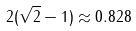Convert formula to latex. <formula><loc_0><loc_0><loc_500><loc_500>2 ( \sqrt { 2 } - 1 ) \approx 0 . 8 2 8</formula> 